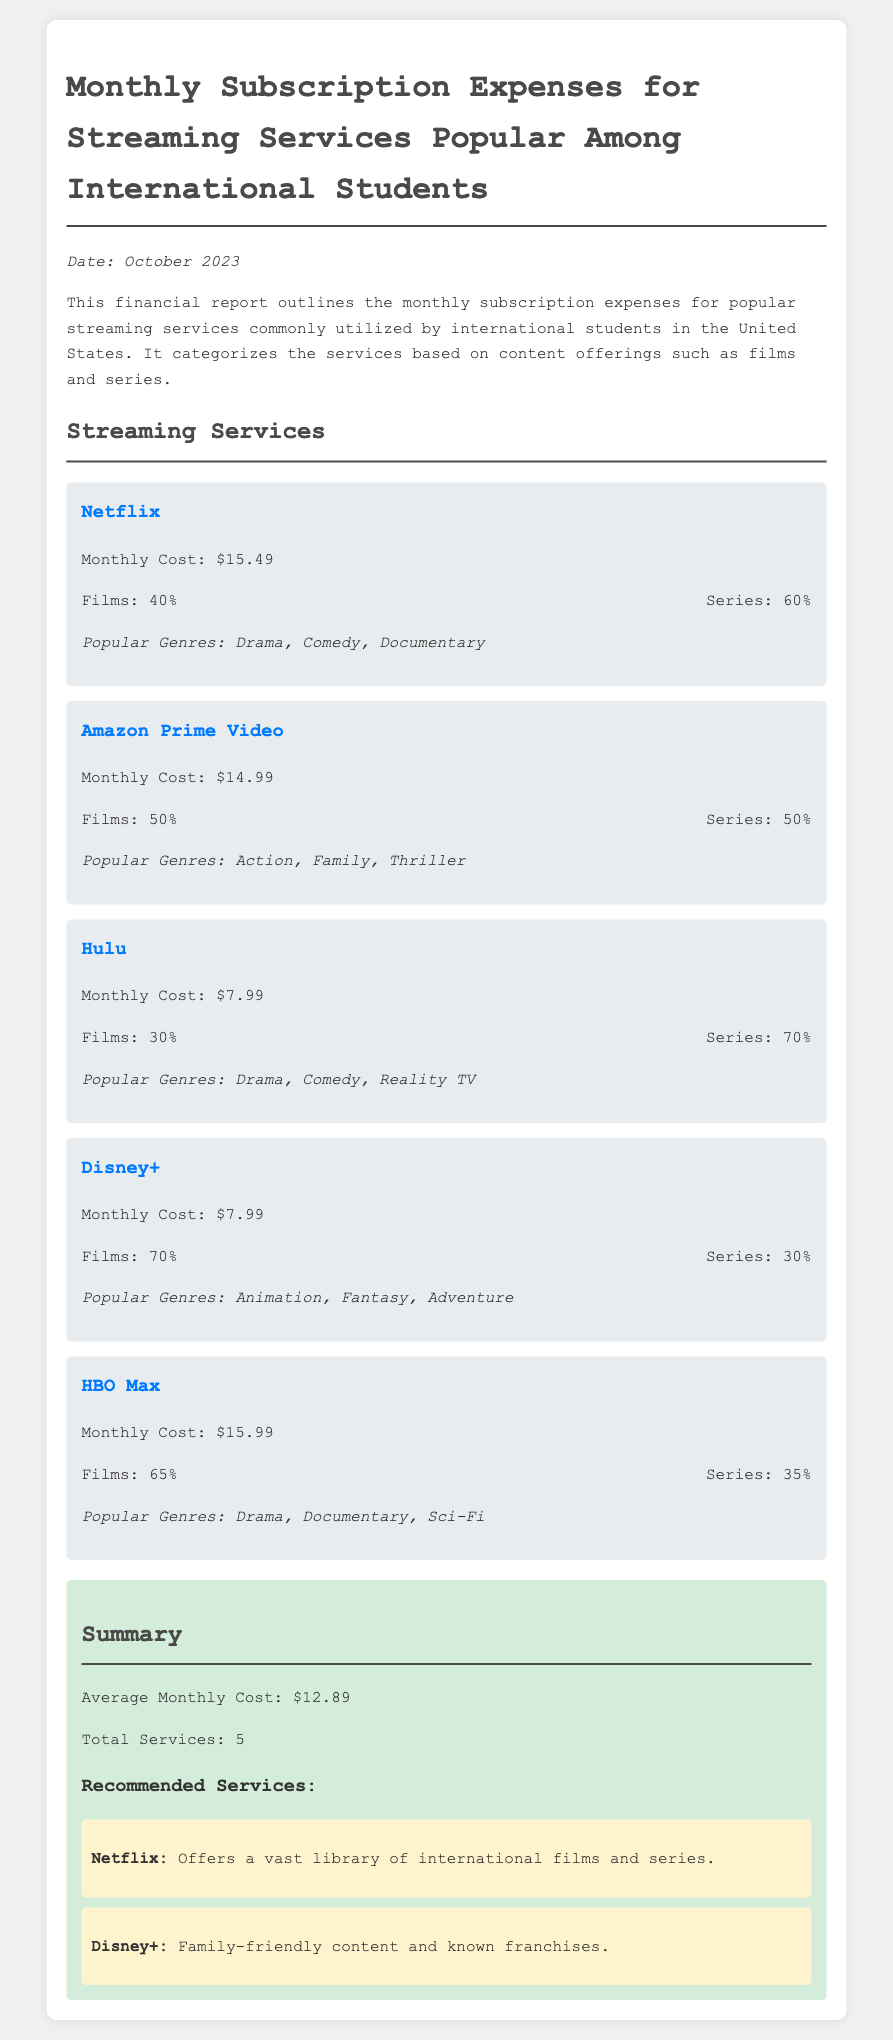What is the monthly cost of Netflix? The monthly cost of Netflix is directly mentioned in the document.
Answer: $15.49 What percentage of content on Hulu is films? The document provides a breakdown of content percentages for Hulu, indicating the share of films.
Answer: 30% Which streaming service has a monthly cost of $7.99? The document lists services with their corresponding monthly costs, and two services share this cost.
Answer: Hulu, Disney+ What is the average monthly cost for the streaming services? The average monthly cost is stated in the summary section of the document, calculated from all services.
Answer: $12.89 Which service offers a vast library of international films and series? The document explicitly recommends Netflix for its content offerings.
Answer: Netflix How many streaming services are included in the report? The document summarizes the total number of services discussed.
Answer: 5 What is the percentage breakdown of series content for Amazon Prime Video? The document specifies the content type distribution for Amazon Prime Video.
Answer: 50% What are the popular genres for Disney+? The document provides a list of popular genres specific to Disney+.
Answer: Animation, Fantasy, Adventure What is the monthly cost of HBO Max? The document states the monthly cost of HBO Max directly.
Answer: $15.99 